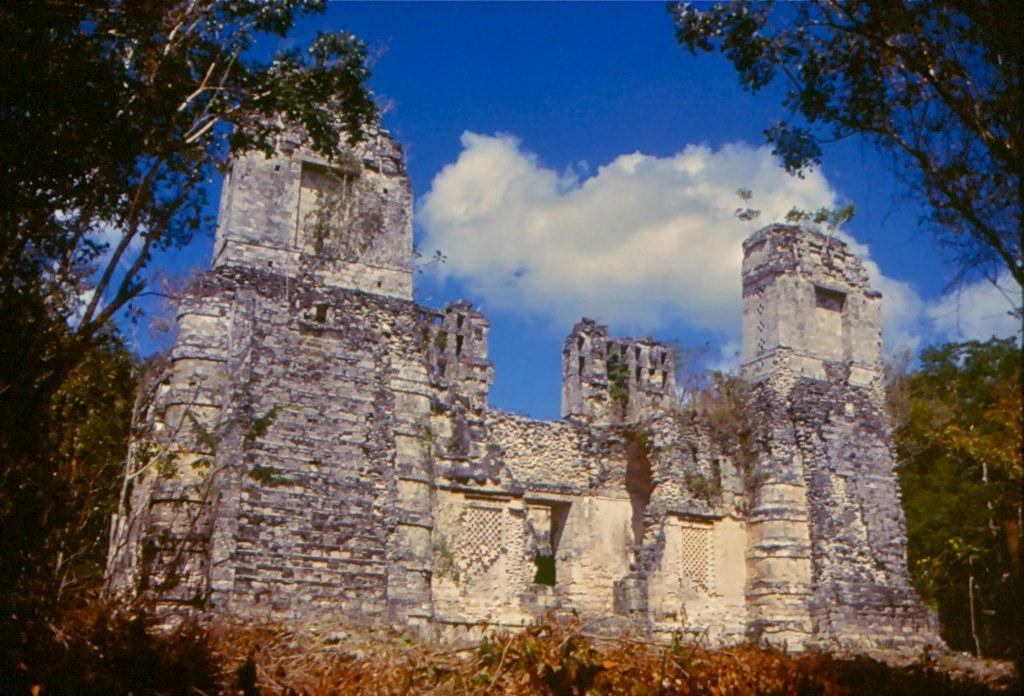What is the main structure in the middle of the image? There is a building in the middle of the image. What type of vegetation can be seen on both sides of the image? There are trees on the right side and the left side of the image. What is visible at the top of the image? The sky is visible at the top of the image. What can be observed in the sky? Clouds are present in the sky. Can you see any honey dripping from the trees in the image? There is no honey present in the image; it features a building, trees, and clouds in the sky. Is there any indication of a fight happening in the image? There is no indication of a fight in the image; it depicts a building, trees, and clouds in the sky. 